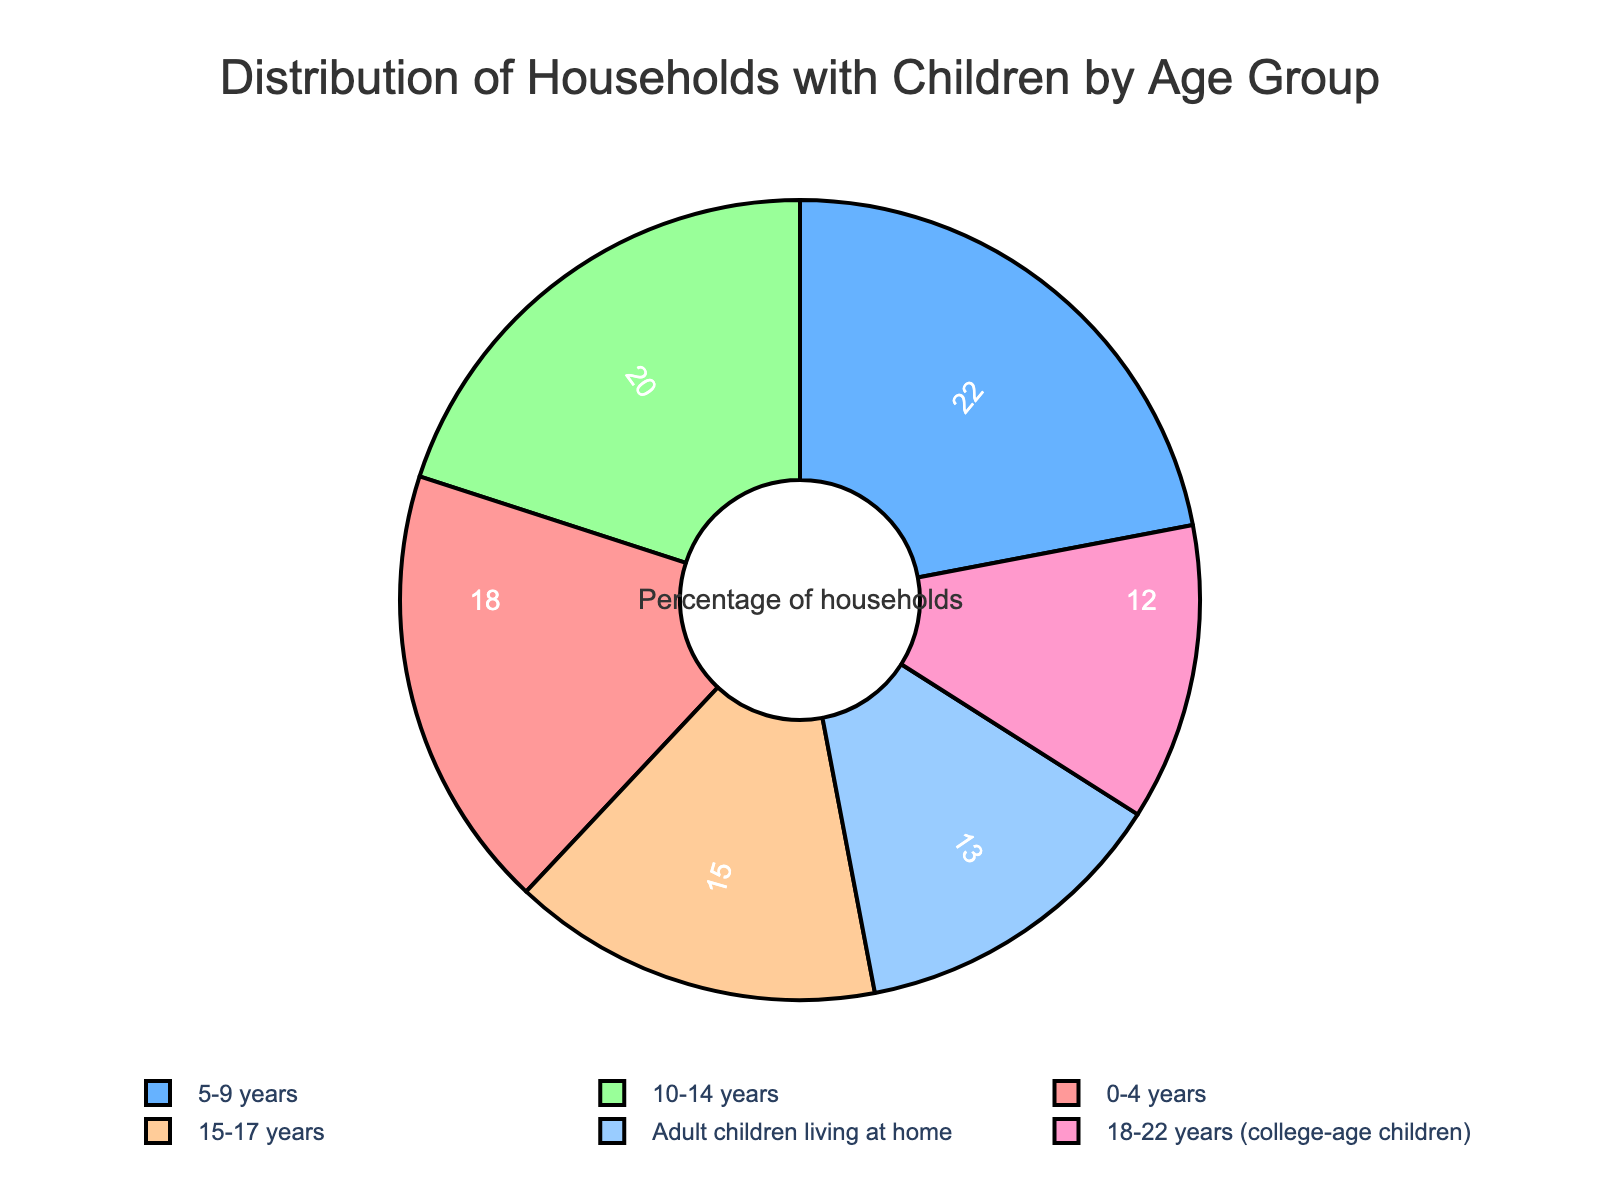What percentage of households have children aged 5-9 years? The pie chart shows a segment labeled "5-9 years" with a specific percentage. Look directly at this segment to find the value.
Answer: 22 Which age group has the smallest percentage of households? Examine all the sections of the pie chart to identify which one has the smallest segment.
Answer: 18-22 years (college-age children) What is the combined percentage of households with children in the age groups 10-14 years and 15-17 years? Add the percentages of the segments labeled "10-14 years" and "15-17 years". The segments show 20% and 15%, respectively. So, 20 + 15 = 35.
Answer: 35 Compare the percentages of households with children aged 0-4 years and adult children living at home. Which group is larger? Locate the segments for "0-4 years" and "Adult children living at home" and compare their percentages. The "0-4 years" segment shows 18% and "Adult children living at home" shows 13%. 18 is greater than 13.
Answer: 0-4 years Which age groups have a percentage of households above 20%? Scan the pie chart and identify all segments with a percentage greater than 20%. These would be "5-9 years" at 22%.
Answer: 5-9 years What's the difference in percentages between households with children aged 0-4 years and 18-22 years? Subtract the percentage of the "18-22 years" segment from the "0-4 years" segment. So, 18 - 12 = 6.
Answer: 6 How many percentage points more are households with children aged 5-9 than those with adult children living at home? Subtract the percentage of "Adult children living at home" from "5-9 years". So, 22 - 13 = 9.
Answer: 9 Which age group has nearly the same percentage of households as adult children living at home? Compare the percentages of each segment with the "Adult children living at home" segment. "18-22 years" at 12% is closest to "Adult children living at home" at 13%.
Answer: 18-22 years (college-age children) What is the total percentage of households with children from 0-9 years? Add the percentages of the segments labeled "0-4 years" and "5-9 years". The segments show 18% and 22%. So, 18 + 22 = 40.
Answer: 40 